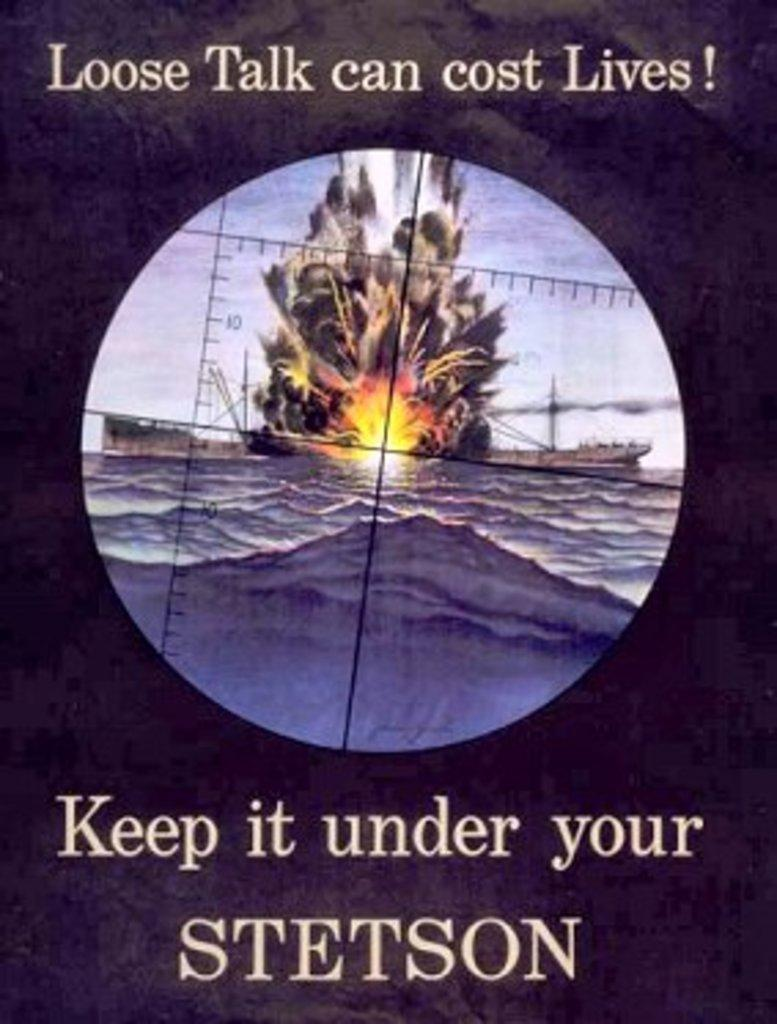<image>
Write a terse but informative summary of the picture. A war poster advises against loose talk because it can cost lives. 